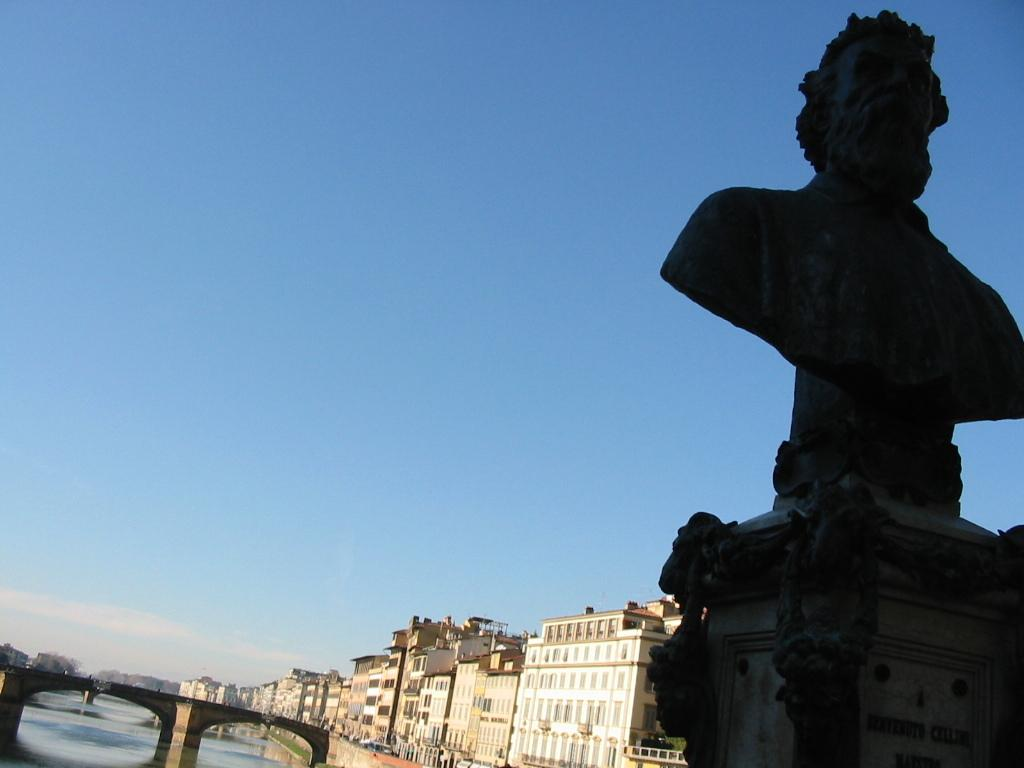What type of water feature is present in the image? There is a canal in the image. How can someone cross the canal in the image? There is a bridge across the canal in the image. What can be seen in the distance in the image? There are buildings in the background of the image. What is visible in the sky in the image? The sky is visible in the background of the image. What artistic element is present on the right side of the image? There is a sculpture on the right side of the image. What type of crayon is being used to draw on the bridge in the image? There is no crayon or drawing present on the bridge in the image. How many dolls are sitting on the sculpture in the image? There are no dolls present in the image, and therefore none are sitting on the sculpture. 